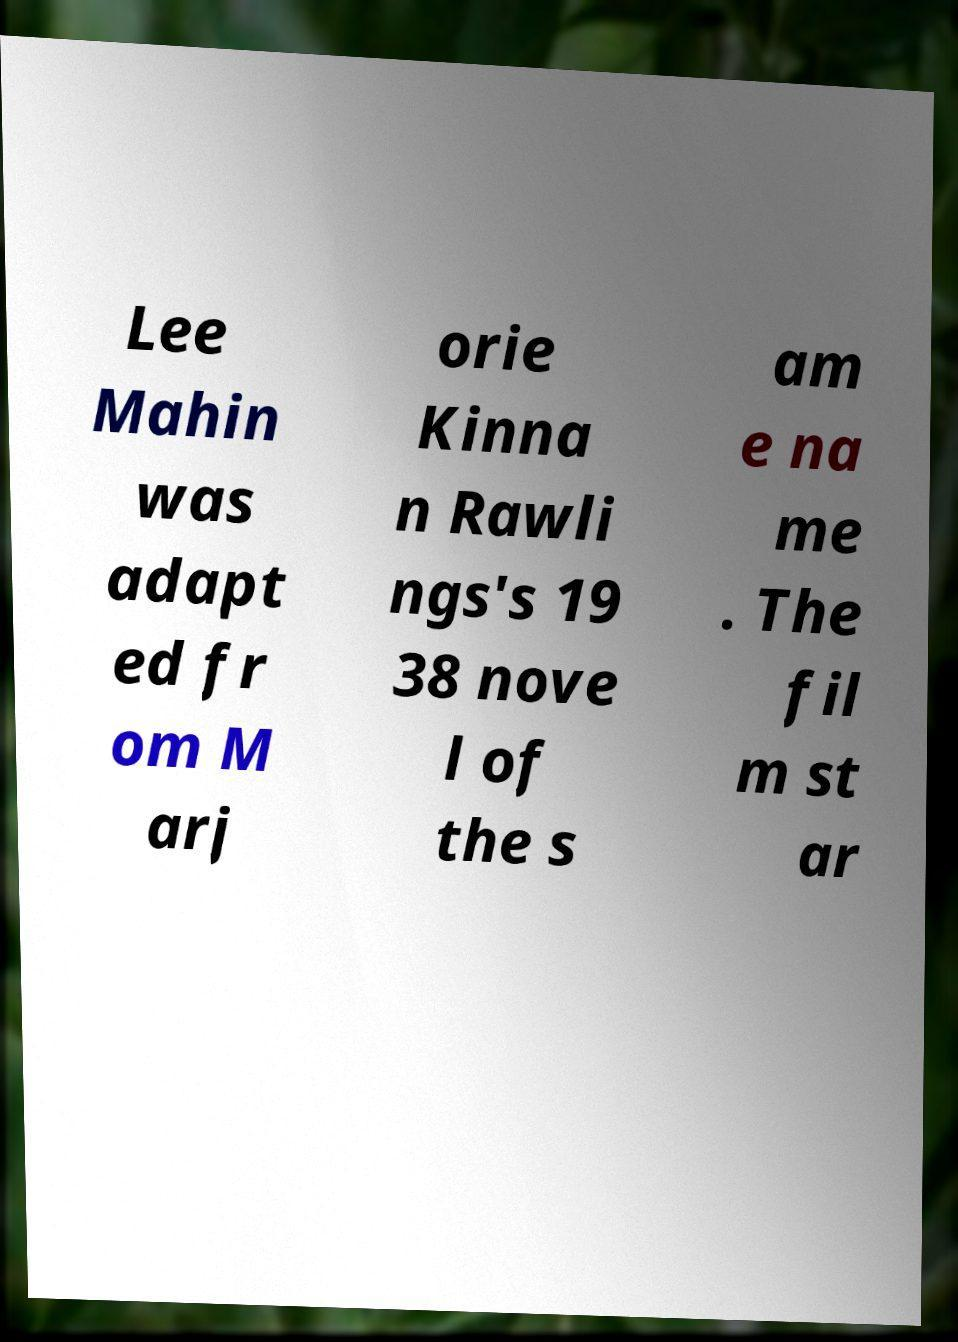Can you read and provide the text displayed in the image?This photo seems to have some interesting text. Can you extract and type it out for me? Lee Mahin was adapt ed fr om M arj orie Kinna n Rawli ngs's 19 38 nove l of the s am e na me . The fil m st ar 